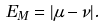Convert formula to latex. <formula><loc_0><loc_0><loc_500><loc_500>E _ { M } = | \mu - \nu | .</formula> 